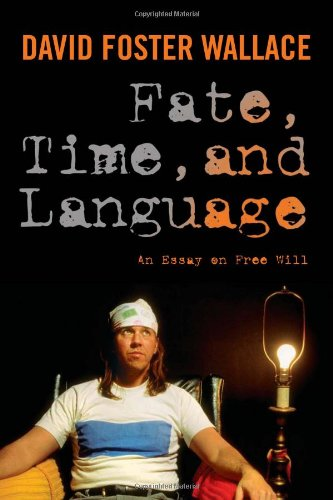What does the presence of the lamp signify in the context of this book cover? The lamp beside David Foster Wallace on the cover likely symbolizes enlightenment or illumination, a nod to the book's themes of exploring deep philosophical questions about fate and free will. How does the lighting affect the overall mood of this image? The soft, focused light from the lamp casts a warm glow, creating a thoughtful and slightly introspective mood which complements the philosophical nature of the book. 